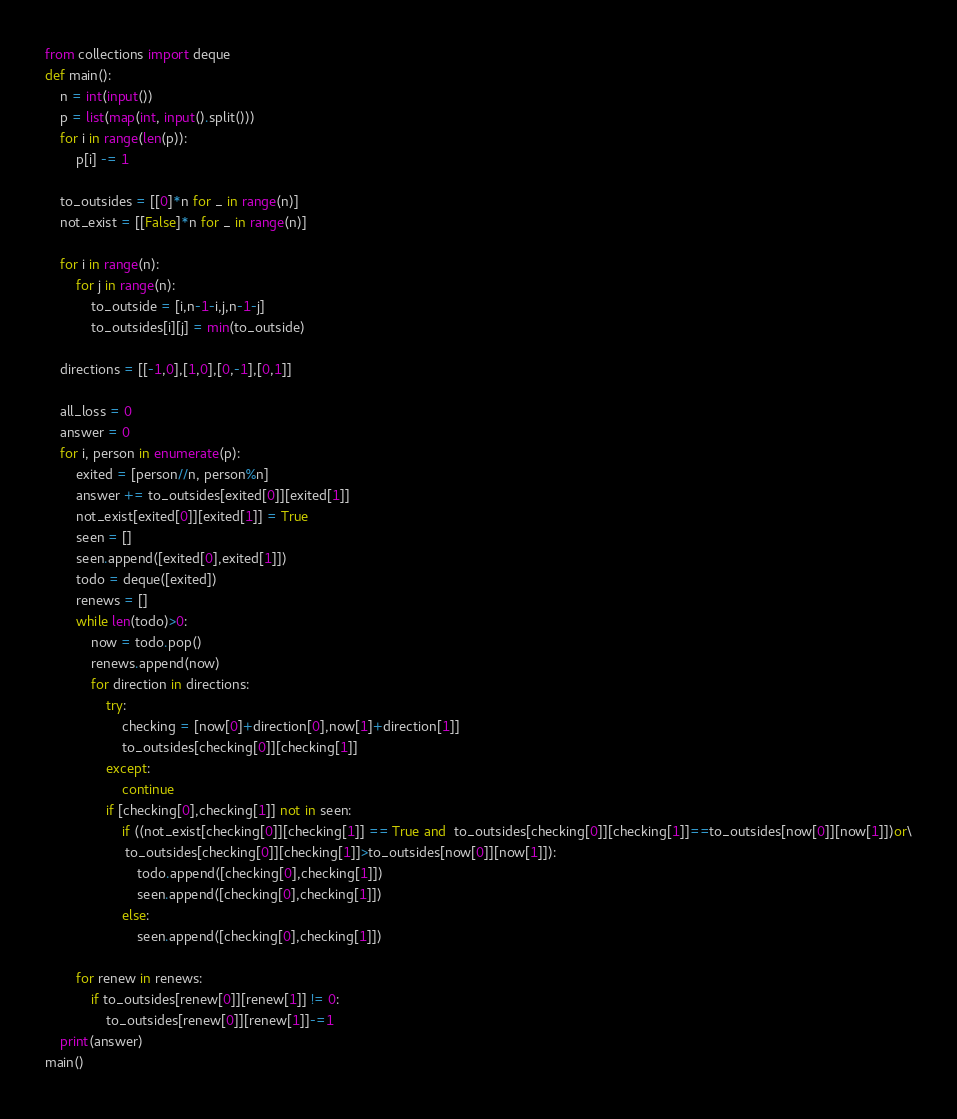<code> <loc_0><loc_0><loc_500><loc_500><_Python_>from collections import deque
def main():
    n = int(input())
    p = list(map(int, input().split()))
    for i in range(len(p)):
        p[i] -= 1
    
    to_outsides = [[0]*n for _ in range(n)]
    not_exist = [[False]*n for _ in range(n)]
    
    for i in range(n):
        for j in range(n):
            to_outside = [i,n-1-i,j,n-1-j]
            to_outsides[i][j] = min(to_outside)
    
    directions = [[-1,0],[1,0],[0,-1],[0,1]]
    
    all_loss = 0
    answer = 0
    for i, person in enumerate(p):
        exited = [person//n, person%n]
        answer += to_outsides[exited[0]][exited[1]]
        not_exist[exited[0]][exited[1]] = True
        seen = []
        seen.append([exited[0],exited[1]])
        todo = deque([exited])
        renews = []
        while len(todo)>0:
            now = todo.pop()
            renews.append(now)
            for direction in directions:
                try:
                    checking = [now[0]+direction[0],now[1]+direction[1]]
                    to_outsides[checking[0]][checking[1]]
                except:
                    continue
                if [checking[0],checking[1]] not in seen:
                    if ((not_exist[checking[0]][checking[1]] == True and  to_outsides[checking[0]][checking[1]]==to_outsides[now[0]][now[1]])or\
                     to_outsides[checking[0]][checking[1]]>to_outsides[now[0]][now[1]]):
                        todo.append([checking[0],checking[1]])
                        seen.append([checking[0],checking[1]])
                    else:
                        seen.append([checking[0],checking[1]])
                        
        for renew in renews:
            if to_outsides[renew[0]][renew[1]] != 0:
                to_outsides[renew[0]][renew[1]]-=1
    print(answer)
main()</code> 